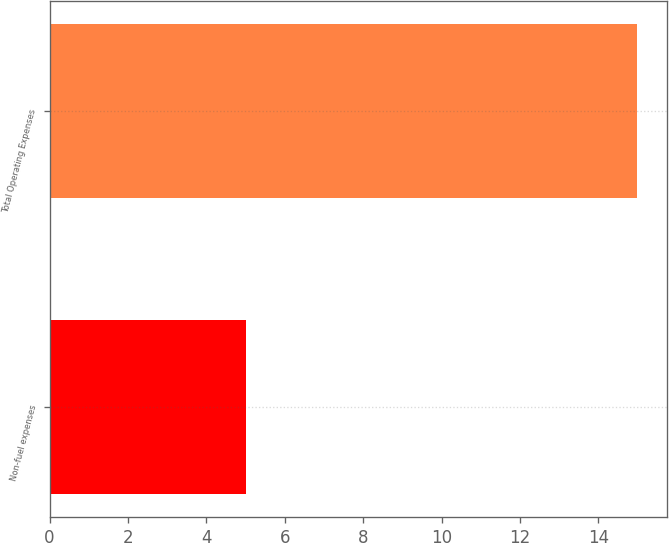Convert chart to OTSL. <chart><loc_0><loc_0><loc_500><loc_500><bar_chart><fcel>Non-fuel expenses<fcel>Total Operating Expenses<nl><fcel>5<fcel>15<nl></chart> 